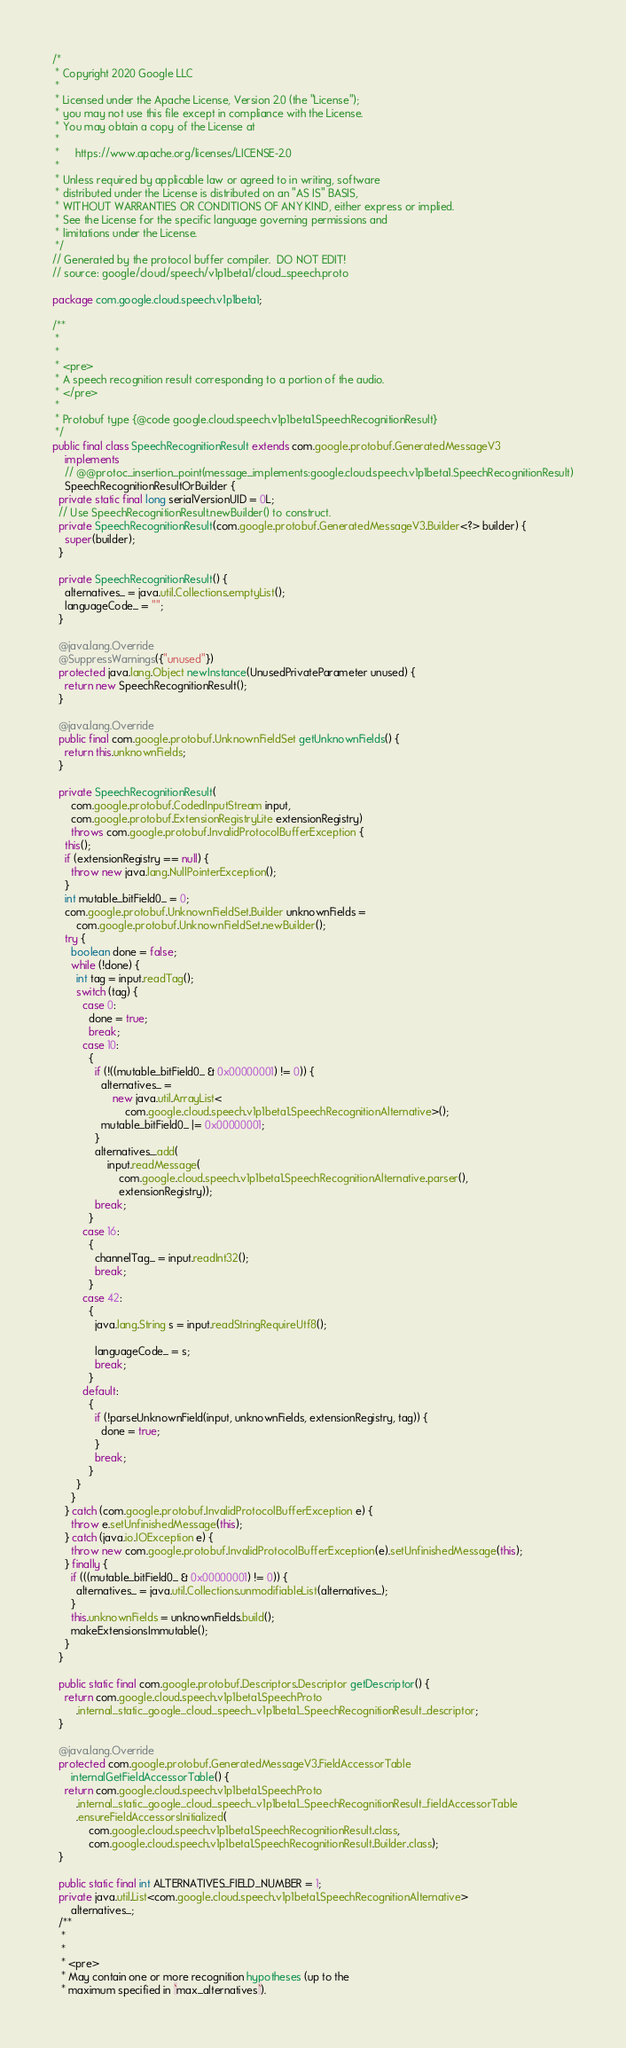Convert code to text. <code><loc_0><loc_0><loc_500><loc_500><_Java_>/*
 * Copyright 2020 Google LLC
 *
 * Licensed under the Apache License, Version 2.0 (the "License");
 * you may not use this file except in compliance with the License.
 * You may obtain a copy of the License at
 *
 *     https://www.apache.org/licenses/LICENSE-2.0
 *
 * Unless required by applicable law or agreed to in writing, software
 * distributed under the License is distributed on an "AS IS" BASIS,
 * WITHOUT WARRANTIES OR CONDITIONS OF ANY KIND, either express or implied.
 * See the License for the specific language governing permissions and
 * limitations under the License.
 */
// Generated by the protocol buffer compiler.  DO NOT EDIT!
// source: google/cloud/speech/v1p1beta1/cloud_speech.proto

package com.google.cloud.speech.v1p1beta1;

/**
 *
 *
 * <pre>
 * A speech recognition result corresponding to a portion of the audio.
 * </pre>
 *
 * Protobuf type {@code google.cloud.speech.v1p1beta1.SpeechRecognitionResult}
 */
public final class SpeechRecognitionResult extends com.google.protobuf.GeneratedMessageV3
    implements
    // @@protoc_insertion_point(message_implements:google.cloud.speech.v1p1beta1.SpeechRecognitionResult)
    SpeechRecognitionResultOrBuilder {
  private static final long serialVersionUID = 0L;
  // Use SpeechRecognitionResult.newBuilder() to construct.
  private SpeechRecognitionResult(com.google.protobuf.GeneratedMessageV3.Builder<?> builder) {
    super(builder);
  }

  private SpeechRecognitionResult() {
    alternatives_ = java.util.Collections.emptyList();
    languageCode_ = "";
  }

  @java.lang.Override
  @SuppressWarnings({"unused"})
  protected java.lang.Object newInstance(UnusedPrivateParameter unused) {
    return new SpeechRecognitionResult();
  }

  @java.lang.Override
  public final com.google.protobuf.UnknownFieldSet getUnknownFields() {
    return this.unknownFields;
  }

  private SpeechRecognitionResult(
      com.google.protobuf.CodedInputStream input,
      com.google.protobuf.ExtensionRegistryLite extensionRegistry)
      throws com.google.protobuf.InvalidProtocolBufferException {
    this();
    if (extensionRegistry == null) {
      throw new java.lang.NullPointerException();
    }
    int mutable_bitField0_ = 0;
    com.google.protobuf.UnknownFieldSet.Builder unknownFields =
        com.google.protobuf.UnknownFieldSet.newBuilder();
    try {
      boolean done = false;
      while (!done) {
        int tag = input.readTag();
        switch (tag) {
          case 0:
            done = true;
            break;
          case 10:
            {
              if (!((mutable_bitField0_ & 0x00000001) != 0)) {
                alternatives_ =
                    new java.util.ArrayList<
                        com.google.cloud.speech.v1p1beta1.SpeechRecognitionAlternative>();
                mutable_bitField0_ |= 0x00000001;
              }
              alternatives_.add(
                  input.readMessage(
                      com.google.cloud.speech.v1p1beta1.SpeechRecognitionAlternative.parser(),
                      extensionRegistry));
              break;
            }
          case 16:
            {
              channelTag_ = input.readInt32();
              break;
            }
          case 42:
            {
              java.lang.String s = input.readStringRequireUtf8();

              languageCode_ = s;
              break;
            }
          default:
            {
              if (!parseUnknownField(input, unknownFields, extensionRegistry, tag)) {
                done = true;
              }
              break;
            }
        }
      }
    } catch (com.google.protobuf.InvalidProtocolBufferException e) {
      throw e.setUnfinishedMessage(this);
    } catch (java.io.IOException e) {
      throw new com.google.protobuf.InvalidProtocolBufferException(e).setUnfinishedMessage(this);
    } finally {
      if (((mutable_bitField0_ & 0x00000001) != 0)) {
        alternatives_ = java.util.Collections.unmodifiableList(alternatives_);
      }
      this.unknownFields = unknownFields.build();
      makeExtensionsImmutable();
    }
  }

  public static final com.google.protobuf.Descriptors.Descriptor getDescriptor() {
    return com.google.cloud.speech.v1p1beta1.SpeechProto
        .internal_static_google_cloud_speech_v1p1beta1_SpeechRecognitionResult_descriptor;
  }

  @java.lang.Override
  protected com.google.protobuf.GeneratedMessageV3.FieldAccessorTable
      internalGetFieldAccessorTable() {
    return com.google.cloud.speech.v1p1beta1.SpeechProto
        .internal_static_google_cloud_speech_v1p1beta1_SpeechRecognitionResult_fieldAccessorTable
        .ensureFieldAccessorsInitialized(
            com.google.cloud.speech.v1p1beta1.SpeechRecognitionResult.class,
            com.google.cloud.speech.v1p1beta1.SpeechRecognitionResult.Builder.class);
  }

  public static final int ALTERNATIVES_FIELD_NUMBER = 1;
  private java.util.List<com.google.cloud.speech.v1p1beta1.SpeechRecognitionAlternative>
      alternatives_;
  /**
   *
   *
   * <pre>
   * May contain one or more recognition hypotheses (up to the
   * maximum specified in `max_alternatives`).</code> 